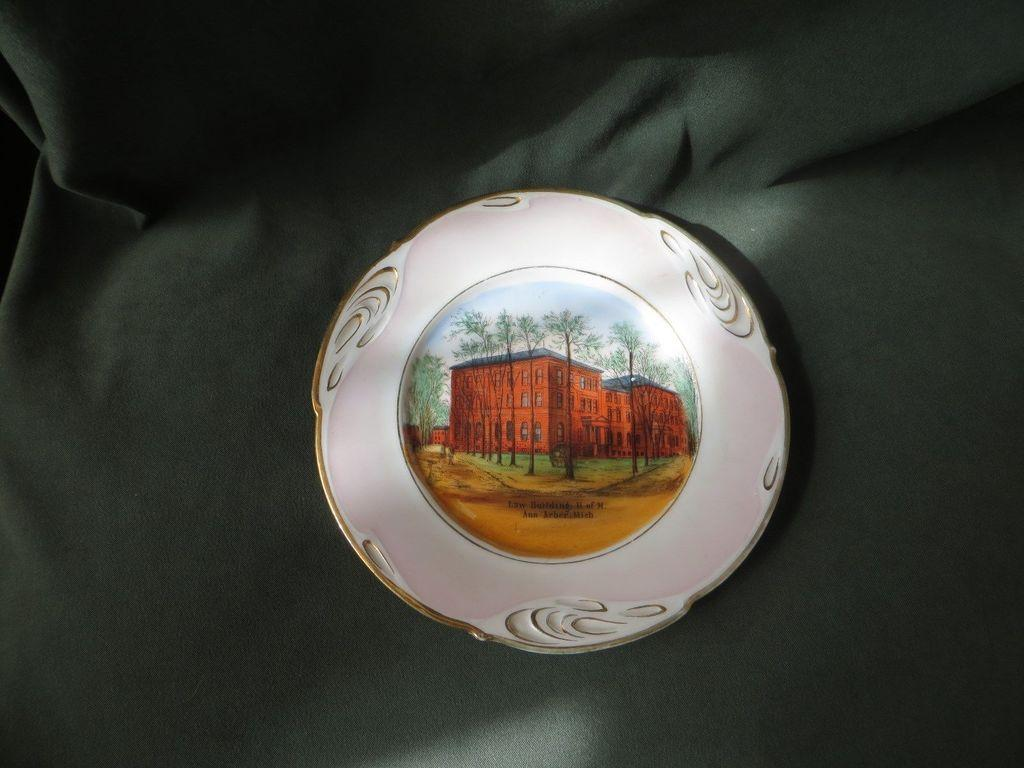What is the main subject of the image? There is an object in the image. What is depicted on the object? The object has a building on it. What type of natural environment is visible in the image? There are trees and sand in the image. Is there any text present in the image? Yes, there is some text on the object. Can you hear the owl hooting in the image? There is no audible sound in the image, and no owl is present. 